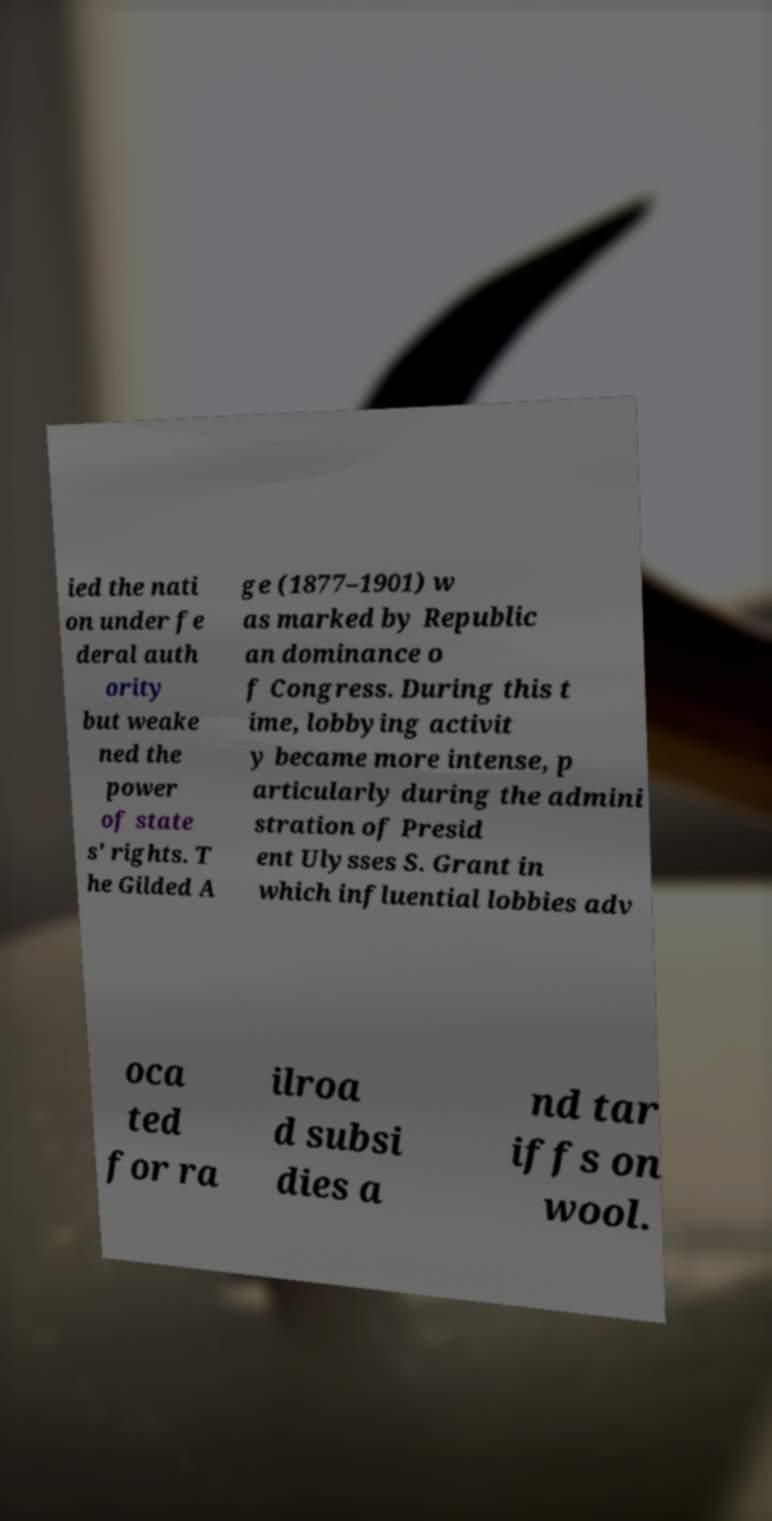Can you accurately transcribe the text from the provided image for me? ied the nati on under fe deral auth ority but weake ned the power of state s' rights. T he Gilded A ge (1877–1901) w as marked by Republic an dominance o f Congress. During this t ime, lobbying activit y became more intense, p articularly during the admini stration of Presid ent Ulysses S. Grant in which influential lobbies adv oca ted for ra ilroa d subsi dies a nd tar iffs on wool. 